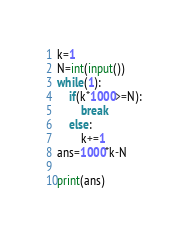Convert code to text. <code><loc_0><loc_0><loc_500><loc_500><_Python_>k=1
N=int(input())
while(1):
    if(k*1000>=N):
        break
    else:
        k+=1
ans=1000*k-N

print(ans)
</code> 